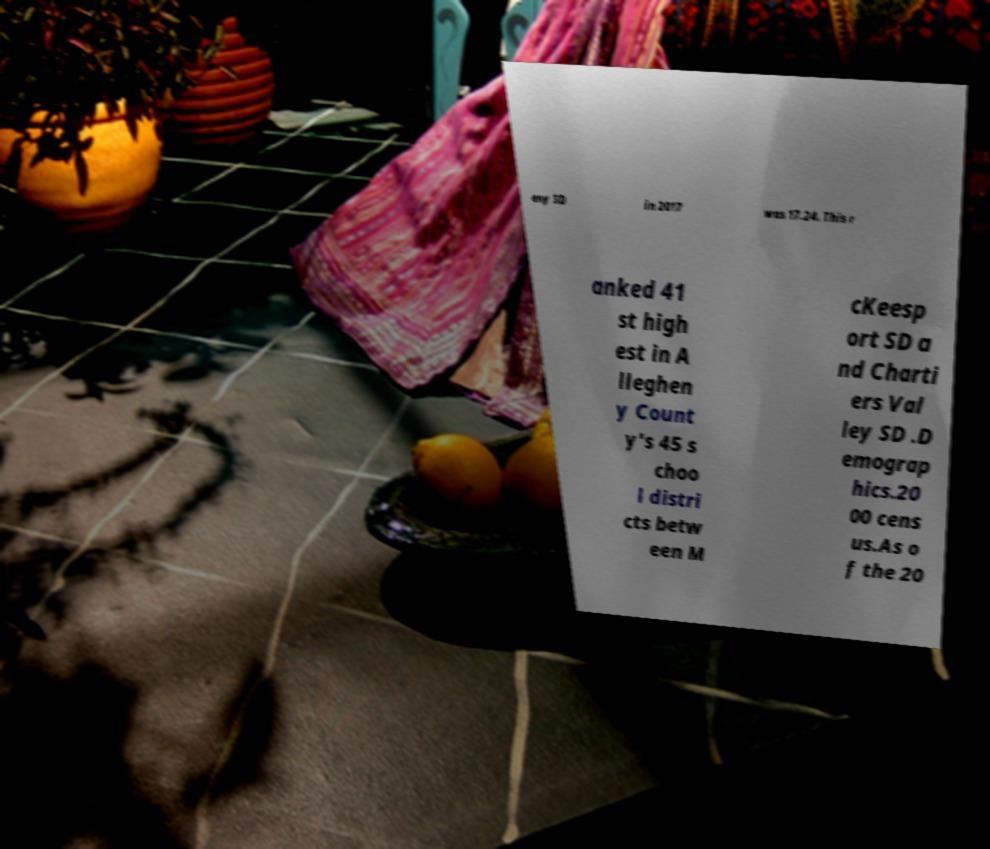For documentation purposes, I need the text within this image transcribed. Could you provide that? eny SD in 2017 was 17.24. This r anked 41 st high est in A lleghen y Count y's 45 s choo l distri cts betw een M cKeesp ort SD a nd Charti ers Val ley SD .D emograp hics.20 00 cens us.As o f the 20 